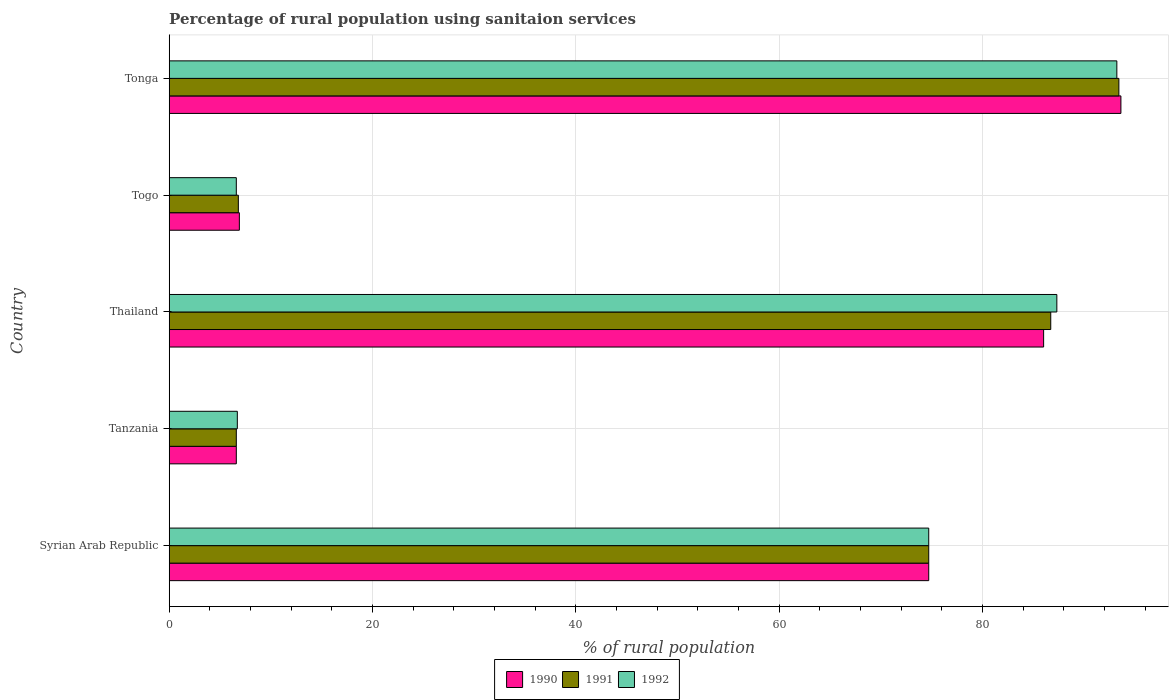How many different coloured bars are there?
Provide a short and direct response. 3. How many groups of bars are there?
Make the answer very short. 5. Are the number of bars on each tick of the Y-axis equal?
Your response must be concise. Yes. How many bars are there on the 2nd tick from the bottom?
Provide a succinct answer. 3. What is the label of the 2nd group of bars from the top?
Offer a very short reply. Togo. What is the percentage of rural population using sanitaion services in 1992 in Thailand?
Offer a terse response. 87.3. Across all countries, what is the maximum percentage of rural population using sanitaion services in 1990?
Give a very brief answer. 93.6. In which country was the percentage of rural population using sanitaion services in 1991 maximum?
Offer a very short reply. Tonga. In which country was the percentage of rural population using sanitaion services in 1990 minimum?
Offer a terse response. Tanzania. What is the total percentage of rural population using sanitaion services in 1991 in the graph?
Give a very brief answer. 268.2. What is the difference between the percentage of rural population using sanitaion services in 1990 in Tanzania and that in Thailand?
Your response must be concise. -79.4. What is the difference between the percentage of rural population using sanitaion services in 1990 in Tonga and the percentage of rural population using sanitaion services in 1992 in Syrian Arab Republic?
Make the answer very short. 18.9. What is the average percentage of rural population using sanitaion services in 1992 per country?
Your answer should be very brief. 53.7. What is the difference between the percentage of rural population using sanitaion services in 1990 and percentage of rural population using sanitaion services in 1991 in Tonga?
Ensure brevity in your answer.  0.2. What is the ratio of the percentage of rural population using sanitaion services in 1990 in Tanzania to that in Togo?
Offer a very short reply. 0.96. Is the percentage of rural population using sanitaion services in 1992 in Tanzania less than that in Thailand?
Offer a terse response. Yes. What is the difference between the highest and the second highest percentage of rural population using sanitaion services in 1991?
Ensure brevity in your answer.  6.7. What is the difference between the highest and the lowest percentage of rural population using sanitaion services in 1992?
Provide a succinct answer. 86.6. In how many countries, is the percentage of rural population using sanitaion services in 1992 greater than the average percentage of rural population using sanitaion services in 1992 taken over all countries?
Your answer should be very brief. 3. What does the 1st bar from the top in Tanzania represents?
Provide a succinct answer. 1992. What does the 1st bar from the bottom in Thailand represents?
Offer a terse response. 1990. Is it the case that in every country, the sum of the percentage of rural population using sanitaion services in 1990 and percentage of rural population using sanitaion services in 1991 is greater than the percentage of rural population using sanitaion services in 1992?
Keep it short and to the point. Yes. How many countries are there in the graph?
Keep it short and to the point. 5. What is the difference between two consecutive major ticks on the X-axis?
Your answer should be compact. 20. Are the values on the major ticks of X-axis written in scientific E-notation?
Give a very brief answer. No. Does the graph contain grids?
Your answer should be very brief. Yes. Where does the legend appear in the graph?
Offer a very short reply. Bottom center. How are the legend labels stacked?
Provide a short and direct response. Horizontal. What is the title of the graph?
Give a very brief answer. Percentage of rural population using sanitaion services. Does "1969" appear as one of the legend labels in the graph?
Give a very brief answer. No. What is the label or title of the X-axis?
Give a very brief answer. % of rural population. What is the % of rural population of 1990 in Syrian Arab Republic?
Your answer should be very brief. 74.7. What is the % of rural population in 1991 in Syrian Arab Republic?
Make the answer very short. 74.7. What is the % of rural population in 1992 in Syrian Arab Republic?
Provide a short and direct response. 74.7. What is the % of rural population of 1990 in Tanzania?
Ensure brevity in your answer.  6.6. What is the % of rural population of 1991 in Tanzania?
Provide a short and direct response. 6.6. What is the % of rural population of 1992 in Tanzania?
Give a very brief answer. 6.7. What is the % of rural population in 1990 in Thailand?
Make the answer very short. 86. What is the % of rural population of 1991 in Thailand?
Provide a succinct answer. 86.7. What is the % of rural population in 1992 in Thailand?
Keep it short and to the point. 87.3. What is the % of rural population in 1991 in Togo?
Give a very brief answer. 6.8. What is the % of rural population of 1992 in Togo?
Provide a succinct answer. 6.6. What is the % of rural population in 1990 in Tonga?
Provide a short and direct response. 93.6. What is the % of rural population in 1991 in Tonga?
Keep it short and to the point. 93.4. What is the % of rural population in 1992 in Tonga?
Ensure brevity in your answer.  93.2. Across all countries, what is the maximum % of rural population of 1990?
Provide a succinct answer. 93.6. Across all countries, what is the maximum % of rural population in 1991?
Offer a very short reply. 93.4. Across all countries, what is the maximum % of rural population of 1992?
Offer a terse response. 93.2. Across all countries, what is the minimum % of rural population in 1991?
Keep it short and to the point. 6.6. Across all countries, what is the minimum % of rural population of 1992?
Offer a terse response. 6.6. What is the total % of rural population of 1990 in the graph?
Offer a terse response. 267.8. What is the total % of rural population in 1991 in the graph?
Keep it short and to the point. 268.2. What is the total % of rural population in 1992 in the graph?
Keep it short and to the point. 268.5. What is the difference between the % of rural population of 1990 in Syrian Arab Republic and that in Tanzania?
Offer a terse response. 68.1. What is the difference between the % of rural population in 1991 in Syrian Arab Republic and that in Tanzania?
Your answer should be compact. 68.1. What is the difference between the % of rural population in 1991 in Syrian Arab Republic and that in Thailand?
Give a very brief answer. -12. What is the difference between the % of rural population of 1992 in Syrian Arab Republic and that in Thailand?
Ensure brevity in your answer.  -12.6. What is the difference between the % of rural population of 1990 in Syrian Arab Republic and that in Togo?
Keep it short and to the point. 67.8. What is the difference between the % of rural population in 1991 in Syrian Arab Republic and that in Togo?
Provide a short and direct response. 67.9. What is the difference between the % of rural population in 1992 in Syrian Arab Republic and that in Togo?
Ensure brevity in your answer.  68.1. What is the difference between the % of rural population in 1990 in Syrian Arab Republic and that in Tonga?
Give a very brief answer. -18.9. What is the difference between the % of rural population in 1991 in Syrian Arab Republic and that in Tonga?
Your response must be concise. -18.7. What is the difference between the % of rural population in 1992 in Syrian Arab Republic and that in Tonga?
Your answer should be very brief. -18.5. What is the difference between the % of rural population in 1990 in Tanzania and that in Thailand?
Your response must be concise. -79.4. What is the difference between the % of rural population in 1991 in Tanzania and that in Thailand?
Your answer should be compact. -80.1. What is the difference between the % of rural population of 1992 in Tanzania and that in Thailand?
Ensure brevity in your answer.  -80.6. What is the difference between the % of rural population of 1990 in Tanzania and that in Togo?
Provide a short and direct response. -0.3. What is the difference between the % of rural population of 1991 in Tanzania and that in Togo?
Provide a succinct answer. -0.2. What is the difference between the % of rural population of 1990 in Tanzania and that in Tonga?
Keep it short and to the point. -87. What is the difference between the % of rural population in 1991 in Tanzania and that in Tonga?
Ensure brevity in your answer.  -86.8. What is the difference between the % of rural population in 1992 in Tanzania and that in Tonga?
Offer a terse response. -86.5. What is the difference between the % of rural population in 1990 in Thailand and that in Togo?
Your response must be concise. 79.1. What is the difference between the % of rural population in 1991 in Thailand and that in Togo?
Make the answer very short. 79.9. What is the difference between the % of rural population in 1992 in Thailand and that in Togo?
Your answer should be very brief. 80.7. What is the difference between the % of rural population in 1992 in Thailand and that in Tonga?
Make the answer very short. -5.9. What is the difference between the % of rural population of 1990 in Togo and that in Tonga?
Keep it short and to the point. -86.7. What is the difference between the % of rural population in 1991 in Togo and that in Tonga?
Make the answer very short. -86.6. What is the difference between the % of rural population in 1992 in Togo and that in Tonga?
Your answer should be very brief. -86.6. What is the difference between the % of rural population of 1990 in Syrian Arab Republic and the % of rural population of 1991 in Tanzania?
Provide a succinct answer. 68.1. What is the difference between the % of rural population in 1990 in Syrian Arab Republic and the % of rural population in 1992 in Thailand?
Give a very brief answer. -12.6. What is the difference between the % of rural population in 1990 in Syrian Arab Republic and the % of rural population in 1991 in Togo?
Keep it short and to the point. 67.9. What is the difference between the % of rural population of 1990 in Syrian Arab Republic and the % of rural population of 1992 in Togo?
Make the answer very short. 68.1. What is the difference between the % of rural population of 1991 in Syrian Arab Republic and the % of rural population of 1992 in Togo?
Make the answer very short. 68.1. What is the difference between the % of rural population in 1990 in Syrian Arab Republic and the % of rural population in 1991 in Tonga?
Your answer should be very brief. -18.7. What is the difference between the % of rural population in 1990 in Syrian Arab Republic and the % of rural population in 1992 in Tonga?
Offer a terse response. -18.5. What is the difference between the % of rural population in 1991 in Syrian Arab Republic and the % of rural population in 1992 in Tonga?
Your answer should be compact. -18.5. What is the difference between the % of rural population in 1990 in Tanzania and the % of rural population in 1991 in Thailand?
Provide a short and direct response. -80.1. What is the difference between the % of rural population of 1990 in Tanzania and the % of rural population of 1992 in Thailand?
Give a very brief answer. -80.7. What is the difference between the % of rural population in 1991 in Tanzania and the % of rural population in 1992 in Thailand?
Keep it short and to the point. -80.7. What is the difference between the % of rural population of 1990 in Tanzania and the % of rural population of 1991 in Togo?
Ensure brevity in your answer.  -0.2. What is the difference between the % of rural population in 1990 in Tanzania and the % of rural population in 1991 in Tonga?
Make the answer very short. -86.8. What is the difference between the % of rural population in 1990 in Tanzania and the % of rural population in 1992 in Tonga?
Your answer should be compact. -86.6. What is the difference between the % of rural population in 1991 in Tanzania and the % of rural population in 1992 in Tonga?
Offer a terse response. -86.6. What is the difference between the % of rural population in 1990 in Thailand and the % of rural population in 1991 in Togo?
Offer a very short reply. 79.2. What is the difference between the % of rural population in 1990 in Thailand and the % of rural population in 1992 in Togo?
Offer a very short reply. 79.4. What is the difference between the % of rural population of 1991 in Thailand and the % of rural population of 1992 in Togo?
Your response must be concise. 80.1. What is the difference between the % of rural population of 1990 in Thailand and the % of rural population of 1991 in Tonga?
Your response must be concise. -7.4. What is the difference between the % of rural population in 1991 in Thailand and the % of rural population in 1992 in Tonga?
Offer a very short reply. -6.5. What is the difference between the % of rural population of 1990 in Togo and the % of rural population of 1991 in Tonga?
Offer a terse response. -86.5. What is the difference between the % of rural population in 1990 in Togo and the % of rural population in 1992 in Tonga?
Ensure brevity in your answer.  -86.3. What is the difference between the % of rural population in 1991 in Togo and the % of rural population in 1992 in Tonga?
Provide a short and direct response. -86.4. What is the average % of rural population in 1990 per country?
Your answer should be very brief. 53.56. What is the average % of rural population in 1991 per country?
Offer a terse response. 53.64. What is the average % of rural population of 1992 per country?
Provide a short and direct response. 53.7. What is the difference between the % of rural population of 1990 and % of rural population of 1991 in Syrian Arab Republic?
Provide a short and direct response. 0. What is the difference between the % of rural population of 1990 and % of rural population of 1992 in Syrian Arab Republic?
Offer a terse response. 0. What is the difference between the % of rural population of 1990 and % of rural population of 1991 in Tanzania?
Give a very brief answer. 0. What is the difference between the % of rural population of 1990 and % of rural population of 1992 in Tanzania?
Your answer should be very brief. -0.1. What is the difference between the % of rural population in 1991 and % of rural population in 1992 in Tanzania?
Provide a succinct answer. -0.1. What is the difference between the % of rural population in 1991 and % of rural population in 1992 in Thailand?
Provide a succinct answer. -0.6. What is the difference between the % of rural population in 1990 and % of rural population in 1991 in Togo?
Provide a short and direct response. 0.1. What is the difference between the % of rural population of 1990 and % of rural population of 1992 in Togo?
Your response must be concise. 0.3. What is the difference between the % of rural population of 1990 and % of rural population of 1991 in Tonga?
Make the answer very short. 0.2. What is the difference between the % of rural population in 1991 and % of rural population in 1992 in Tonga?
Keep it short and to the point. 0.2. What is the ratio of the % of rural population of 1990 in Syrian Arab Republic to that in Tanzania?
Make the answer very short. 11.32. What is the ratio of the % of rural population in 1991 in Syrian Arab Republic to that in Tanzania?
Offer a very short reply. 11.32. What is the ratio of the % of rural population of 1992 in Syrian Arab Republic to that in Tanzania?
Keep it short and to the point. 11.15. What is the ratio of the % of rural population of 1990 in Syrian Arab Republic to that in Thailand?
Offer a terse response. 0.87. What is the ratio of the % of rural population of 1991 in Syrian Arab Republic to that in Thailand?
Your answer should be compact. 0.86. What is the ratio of the % of rural population of 1992 in Syrian Arab Republic to that in Thailand?
Provide a succinct answer. 0.86. What is the ratio of the % of rural population of 1990 in Syrian Arab Republic to that in Togo?
Your answer should be very brief. 10.83. What is the ratio of the % of rural population in 1991 in Syrian Arab Republic to that in Togo?
Your answer should be compact. 10.99. What is the ratio of the % of rural population in 1992 in Syrian Arab Republic to that in Togo?
Provide a succinct answer. 11.32. What is the ratio of the % of rural population in 1990 in Syrian Arab Republic to that in Tonga?
Ensure brevity in your answer.  0.8. What is the ratio of the % of rural population in 1991 in Syrian Arab Republic to that in Tonga?
Provide a short and direct response. 0.8. What is the ratio of the % of rural population in 1992 in Syrian Arab Republic to that in Tonga?
Your response must be concise. 0.8. What is the ratio of the % of rural population in 1990 in Tanzania to that in Thailand?
Give a very brief answer. 0.08. What is the ratio of the % of rural population of 1991 in Tanzania to that in Thailand?
Give a very brief answer. 0.08. What is the ratio of the % of rural population in 1992 in Tanzania to that in Thailand?
Provide a succinct answer. 0.08. What is the ratio of the % of rural population of 1990 in Tanzania to that in Togo?
Provide a short and direct response. 0.96. What is the ratio of the % of rural population of 1991 in Tanzania to that in Togo?
Offer a very short reply. 0.97. What is the ratio of the % of rural population of 1992 in Tanzania to that in Togo?
Provide a short and direct response. 1.02. What is the ratio of the % of rural population in 1990 in Tanzania to that in Tonga?
Your answer should be compact. 0.07. What is the ratio of the % of rural population of 1991 in Tanzania to that in Tonga?
Offer a terse response. 0.07. What is the ratio of the % of rural population of 1992 in Tanzania to that in Tonga?
Your answer should be very brief. 0.07. What is the ratio of the % of rural population in 1990 in Thailand to that in Togo?
Offer a terse response. 12.46. What is the ratio of the % of rural population of 1991 in Thailand to that in Togo?
Provide a succinct answer. 12.75. What is the ratio of the % of rural population in 1992 in Thailand to that in Togo?
Your answer should be very brief. 13.23. What is the ratio of the % of rural population of 1990 in Thailand to that in Tonga?
Provide a succinct answer. 0.92. What is the ratio of the % of rural population in 1991 in Thailand to that in Tonga?
Keep it short and to the point. 0.93. What is the ratio of the % of rural population of 1992 in Thailand to that in Tonga?
Offer a very short reply. 0.94. What is the ratio of the % of rural population in 1990 in Togo to that in Tonga?
Your answer should be compact. 0.07. What is the ratio of the % of rural population in 1991 in Togo to that in Tonga?
Your response must be concise. 0.07. What is the ratio of the % of rural population of 1992 in Togo to that in Tonga?
Offer a very short reply. 0.07. What is the difference between the highest and the lowest % of rural population of 1991?
Give a very brief answer. 86.8. What is the difference between the highest and the lowest % of rural population in 1992?
Your response must be concise. 86.6. 